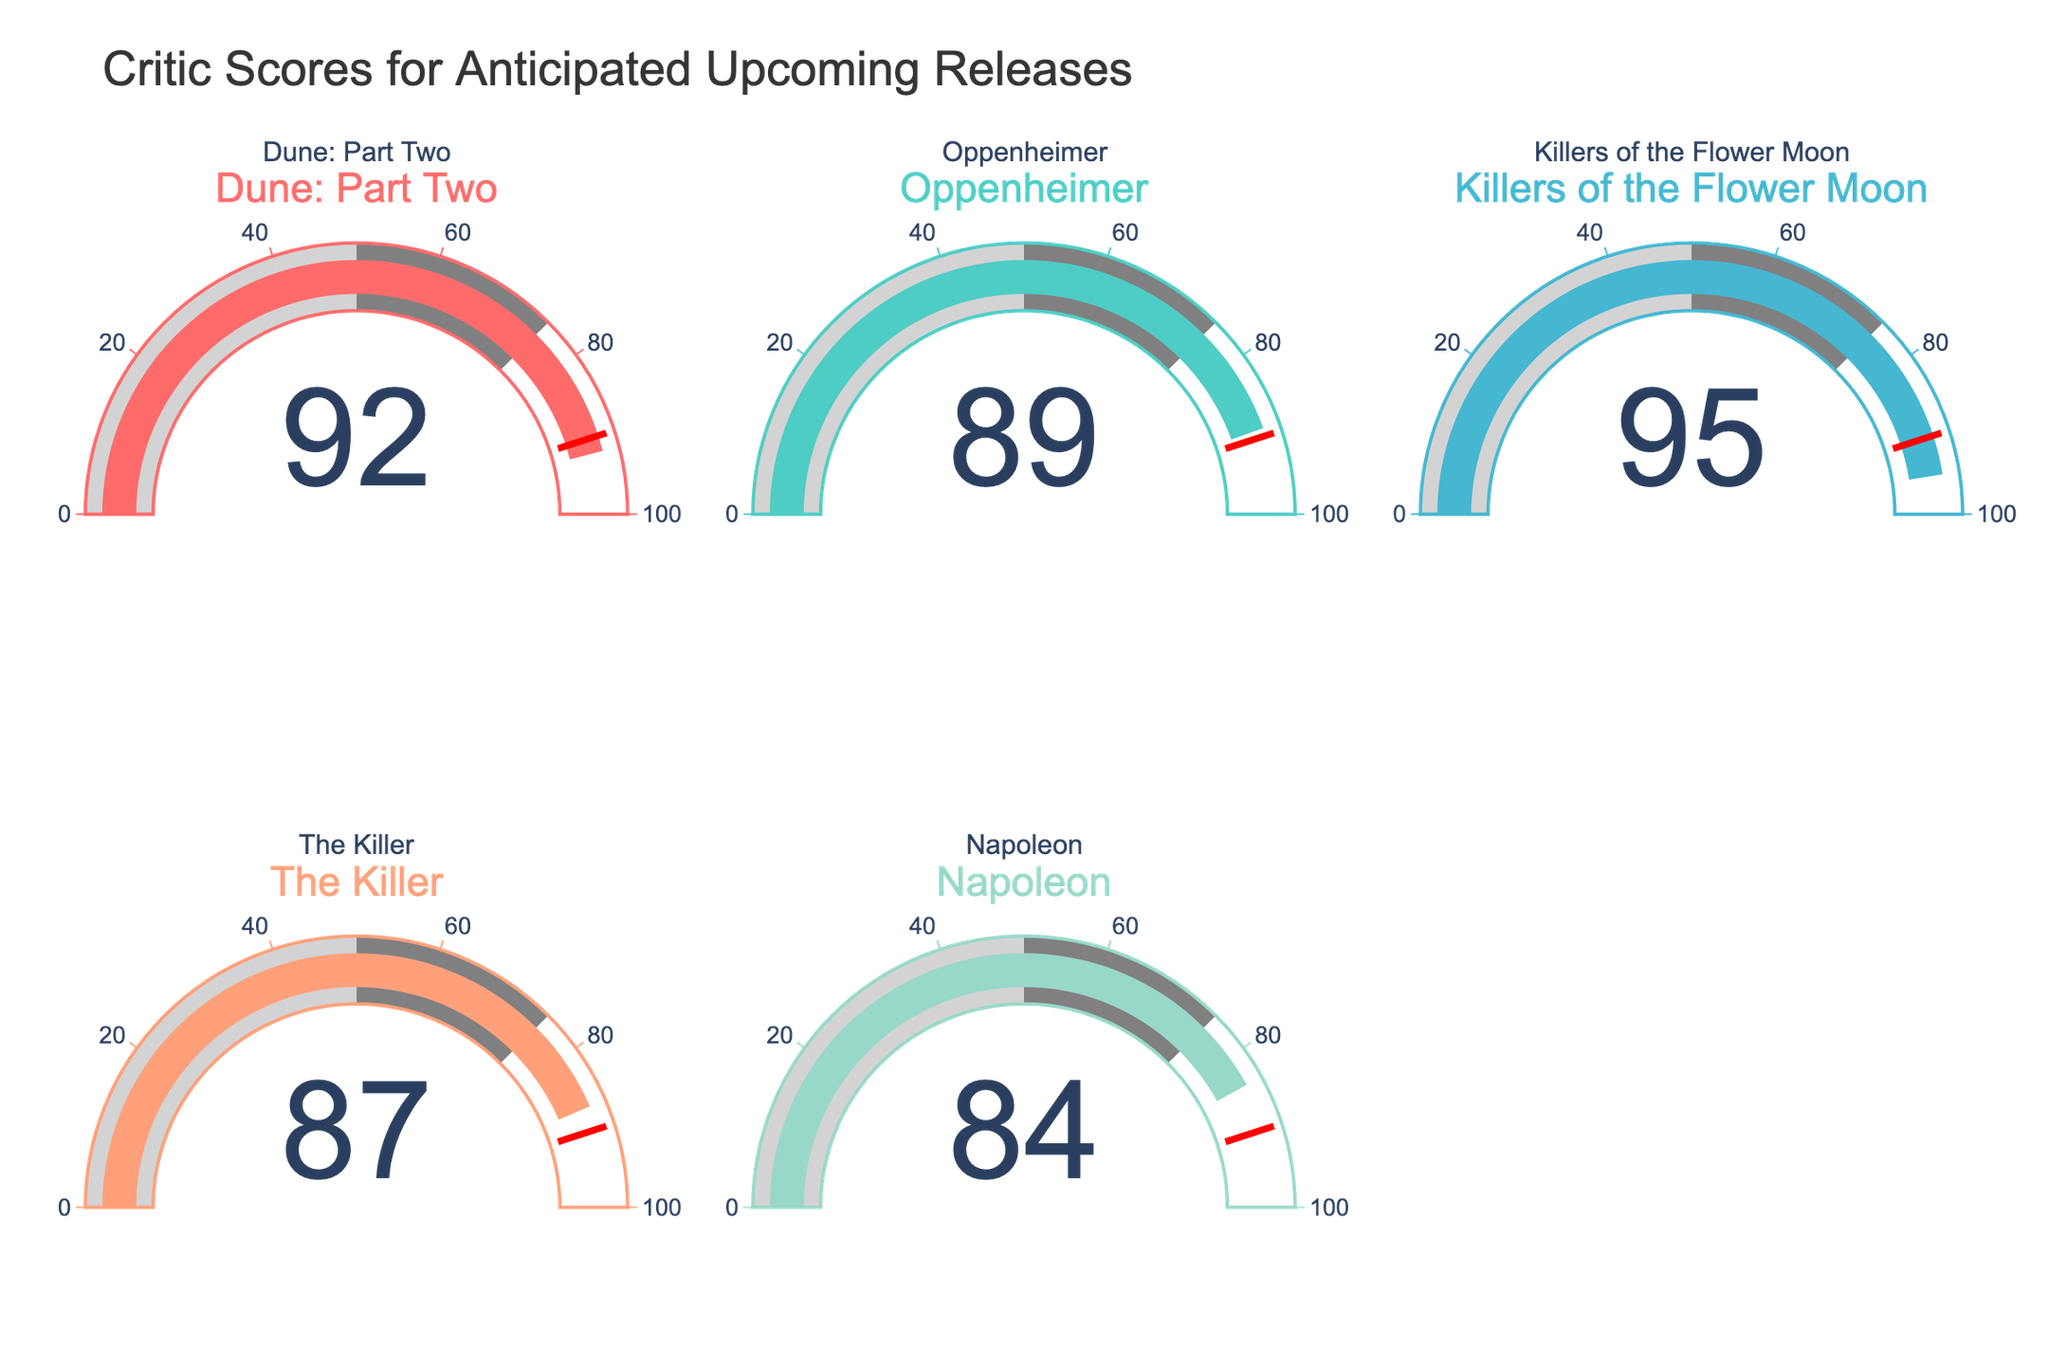What is the title of the figure? The title is located at the top of the figure. It reads "Critic Scores for Anticipated Upcoming Releases."
Answer: Critic Scores for Anticipated Upcoming Releases What is the critic score for "Oppenheimer"? The gauge for "Oppenheimer" shows a value in its center. The number displayed is 89.
Answer: 89 Which movie has the lowest critic score? Looking at the values in the center of each gauge, note the smallest number. It is 84 for "Napoleon."
Answer: Napoleon How many movies have a critic score greater than 90? Identify the gauges with values greater than 90. "Dune: Part Two" (92) and "Killers of the Flower Moon" (95) meet this criterion. There are 2 movies.
Answer: 2 What is the average critic score for all the movies? Add up all the critic scores: 92 + 89 + 95 + 87 + 84 = 447. Then, divide by the number of movies, which is 5. The calculation is 447 / 5 = 89.4.
Answer: 89.4 Which movie has the highest score, and what is that score? Compare all the values displayed on the gauges. The highest score is 95 for "Killers of the Flower Moon."
Answer: Killers of the Flower Moon, 95 What is the total sum of the critic scores for "Dune: Part Two" and "The Killer"? Add the critic score of "Dune: Part Two" (92) and "The Killer" (87). The calculation is 92 + 87 = 179.
Answer: 179 Is there any movie with a score equal to the threshold value indicated by the red line? The red line indicates the threshold value of 90. None of the gauges show exactly 90.
Answer: No Which movie has a closer critic score to "Oppenheimer": "Dune: Part Two" or "Napoleon"? "Oppenheimer" has a score of 89. Compare the differences: 92 - 89 = 3 for "Dune: Part Two" and 89 - 84 = 5 for "Napoleon." The smaller difference (3) is with "Dune: Part Two."
Answer: Dune: Part Two By how much does "Killers of the Flower Moon" score exceed "Napoleon"? Subtract the score of "Napoleon" (84) from "Killers of the Flower Moon" (95). The calculation is 95 - 84 = 11.
Answer: 11 